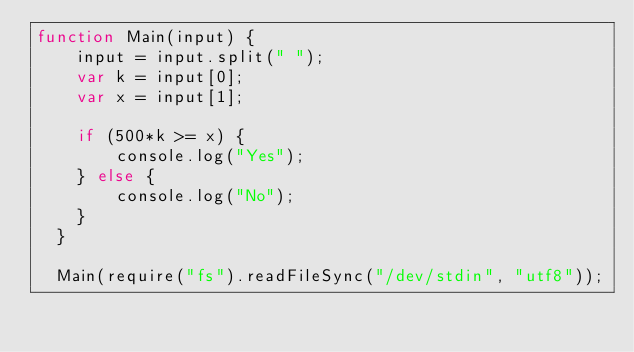<code> <loc_0><loc_0><loc_500><loc_500><_JavaScript_>function Main(input) {
    input = input.split(" ");
    var k = input[0];
    var x = input[1];

    if (500*k >= x) {
        console.log("Yes");
    } else {
        console.log("No");
    }
  }
   
  Main(require("fs").readFileSync("/dev/stdin", "utf8"));
</code> 